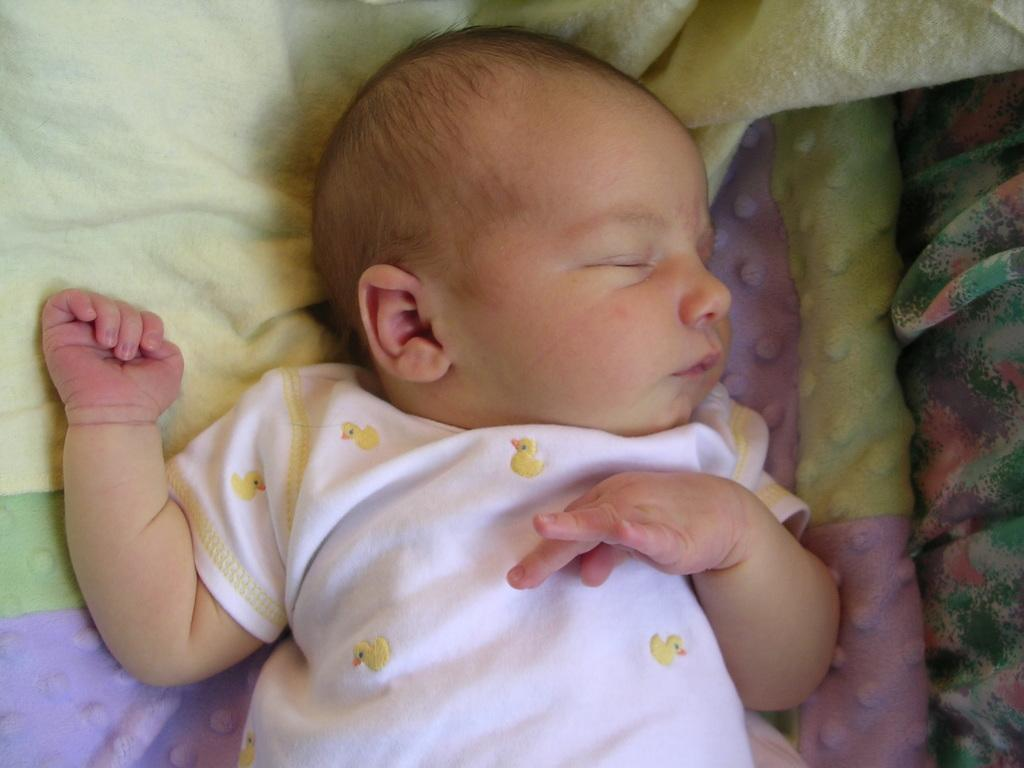What is the main subject of the image? There is a baby in the center of the image. What is the baby doing in the image? The baby is sleeping. What can be seen in the background of the image? There are blankets in the background of the image. Can you tell me how many snails are crawling on the baby's forehead in the image? There are no snails present in the image; the baby is sleeping with blankets in the background. 